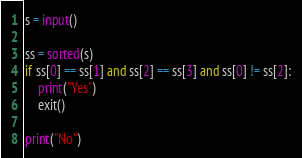Convert code to text. <code><loc_0><loc_0><loc_500><loc_500><_Python_>s = input()

ss = sorted(s)
if ss[0] == ss[1] and ss[2] == ss[3] and ss[0] != ss[2]:
    print("Yes")
    exit()

print("No")</code> 